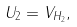<formula> <loc_0><loc_0><loc_500><loc_500>U _ { 2 } = V _ { H _ { 2 } } ,</formula> 